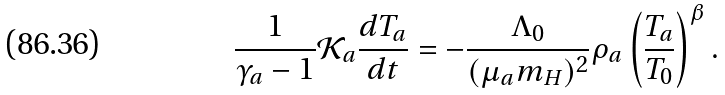<formula> <loc_0><loc_0><loc_500><loc_500>\frac { 1 } { \gamma _ { a } - 1 } \mathcal { K } _ { a } \frac { d T _ { a } } { d t } = - \frac { \Lambda _ { 0 } } { ( \mu _ { a } m _ { H } ) ^ { 2 } } \rho _ { a } \left ( \frac { T _ { a } } { T _ { 0 } } \right ) ^ { \beta } .</formula> 